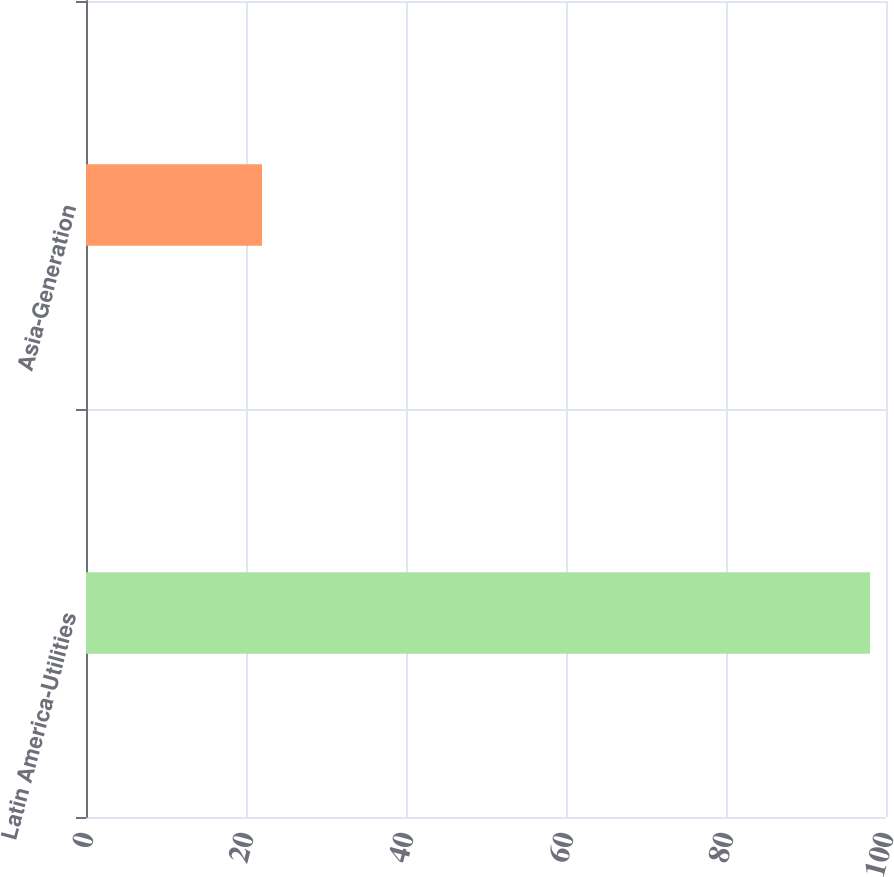<chart> <loc_0><loc_0><loc_500><loc_500><bar_chart><fcel>Latin America-Utilities<fcel>Asia-Generation<nl><fcel>98<fcel>22<nl></chart> 